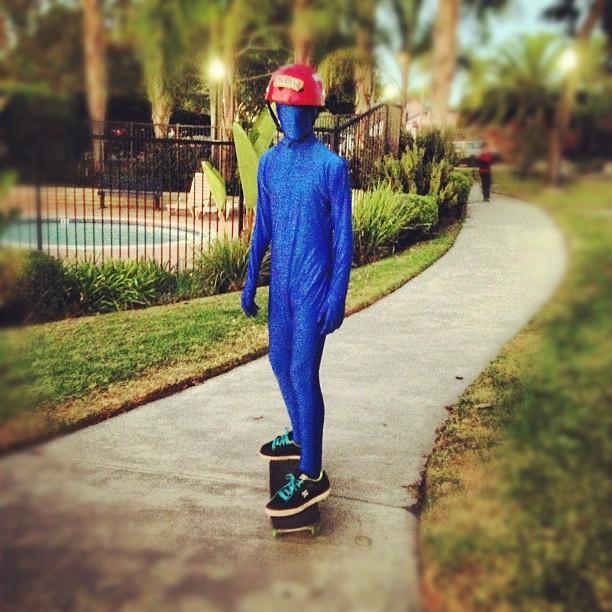What is the man riding?
Give a very brief answer. Skateboard. What color is the person's suit?
Quick response, please. Blue. Is this man someone you would see inside of the White House?
Short answer required. No. 